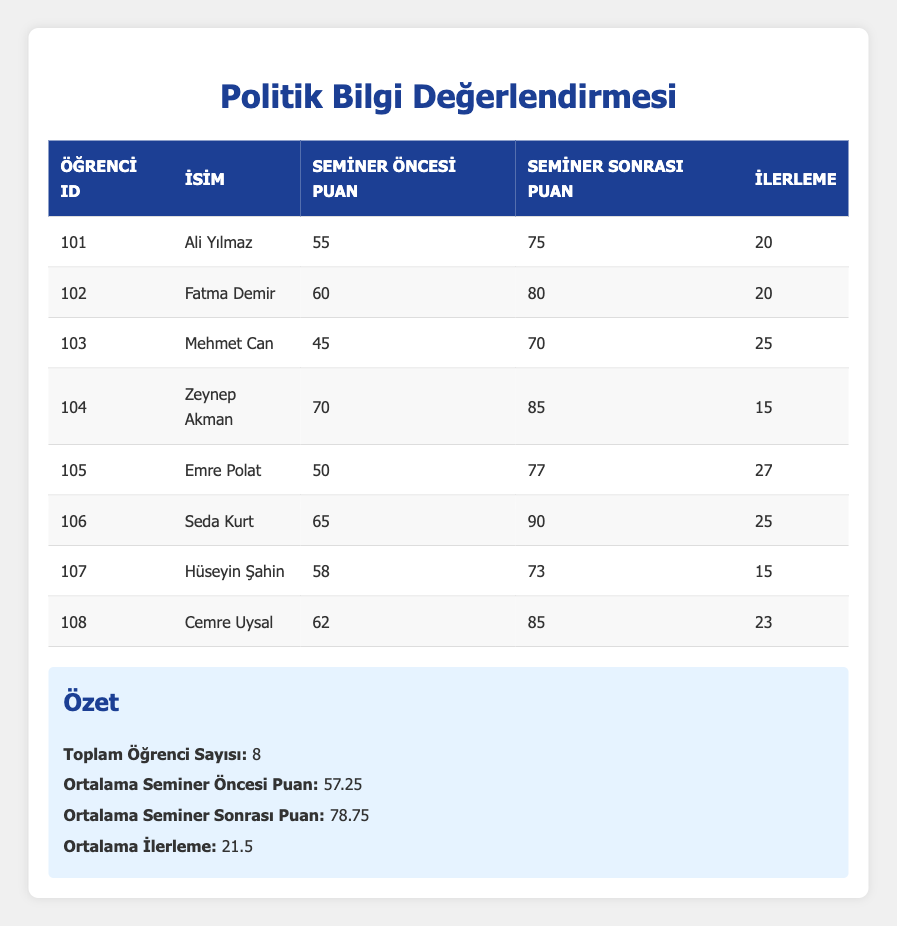What is the pre-seminar knowledge score of Fatma Demir? The table shows that Fatma Demir's pre-seminar knowledge score is listed directly, which is 60.
Answer: 60 What is the improvement score of Emre Polat? By looking at the table, Emre Polat's improvement score is given as 27.
Answer: 27 Who has the highest post-seminar knowledge score? By comparing the post-seminar knowledge scores listed in the table, Seda Kurt has the highest score at 90.
Answer: Seda Kurt Is the average post-seminar knowledge score greater than 80? The average post-seminar knowledge score is stated to be 78.75, which is less than 80, so the answer is no.
Answer: No How much did Mehmet Can improve his knowledge score? The table states that Mehmet Can's improvement is 25, calculated by subtracting his pre-seminar score of 45 from his post-seminar score of 70.
Answer: 25 What is the difference between the highest and lowest pre-seminar knowledge scores? The highest pre-seminar score is 70 (Zeynep Akman) and the lowest is 45 (Mehmet Can), so the difference is 70 - 45 = 25.
Answer: 25 What percentage of students improved their scores by more than 20 points? Out of the 8 students, 5 showed improvements greater than 20 points (Ali Yılmaz, Fatma Demir, Mehmet Can, Emre Polat, Seda Kurt, and Cemre Uysal), so the percentage is (5/8) * 100 = 62.5%.
Answer: 62.5% What is the average improvement score among all students? The table provides an average improvement score calculated as (20 + 20 + 25 + 15 + 27 + 25 + 15 + 23) / 8 = 21.5.
Answer: 21.5 